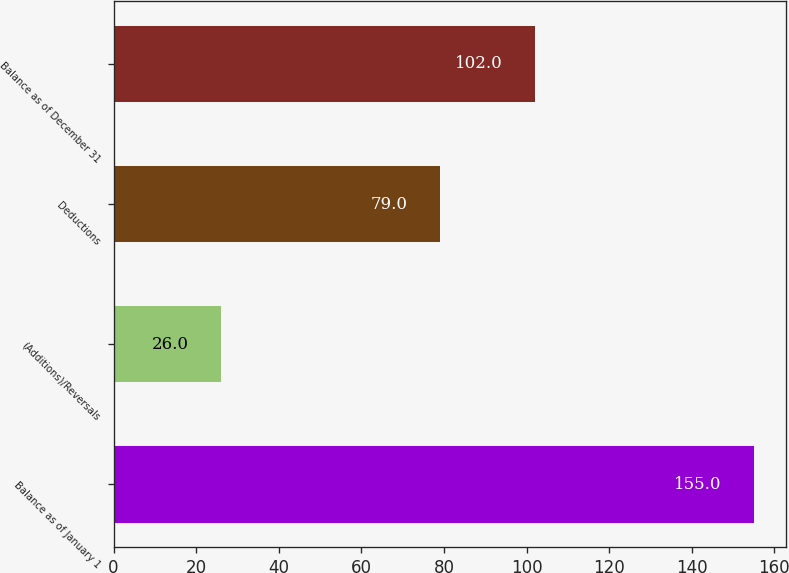<chart> <loc_0><loc_0><loc_500><loc_500><bar_chart><fcel>Balance as of January 1<fcel>(Additions)/Reversals<fcel>Deductions<fcel>Balance as of December 31<nl><fcel>155<fcel>26<fcel>79<fcel>102<nl></chart> 